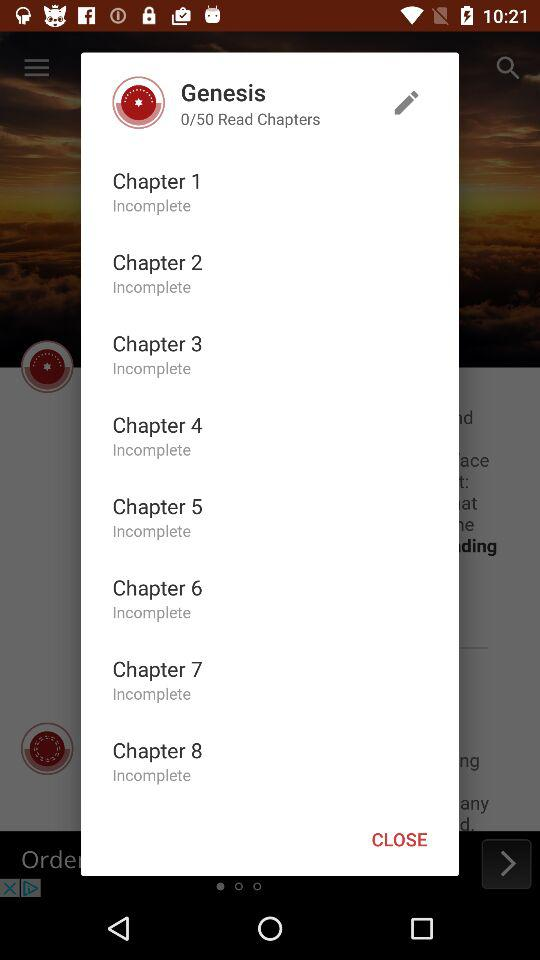What is the status of Chapter 1? The status of chapter 1 is incomplete. 